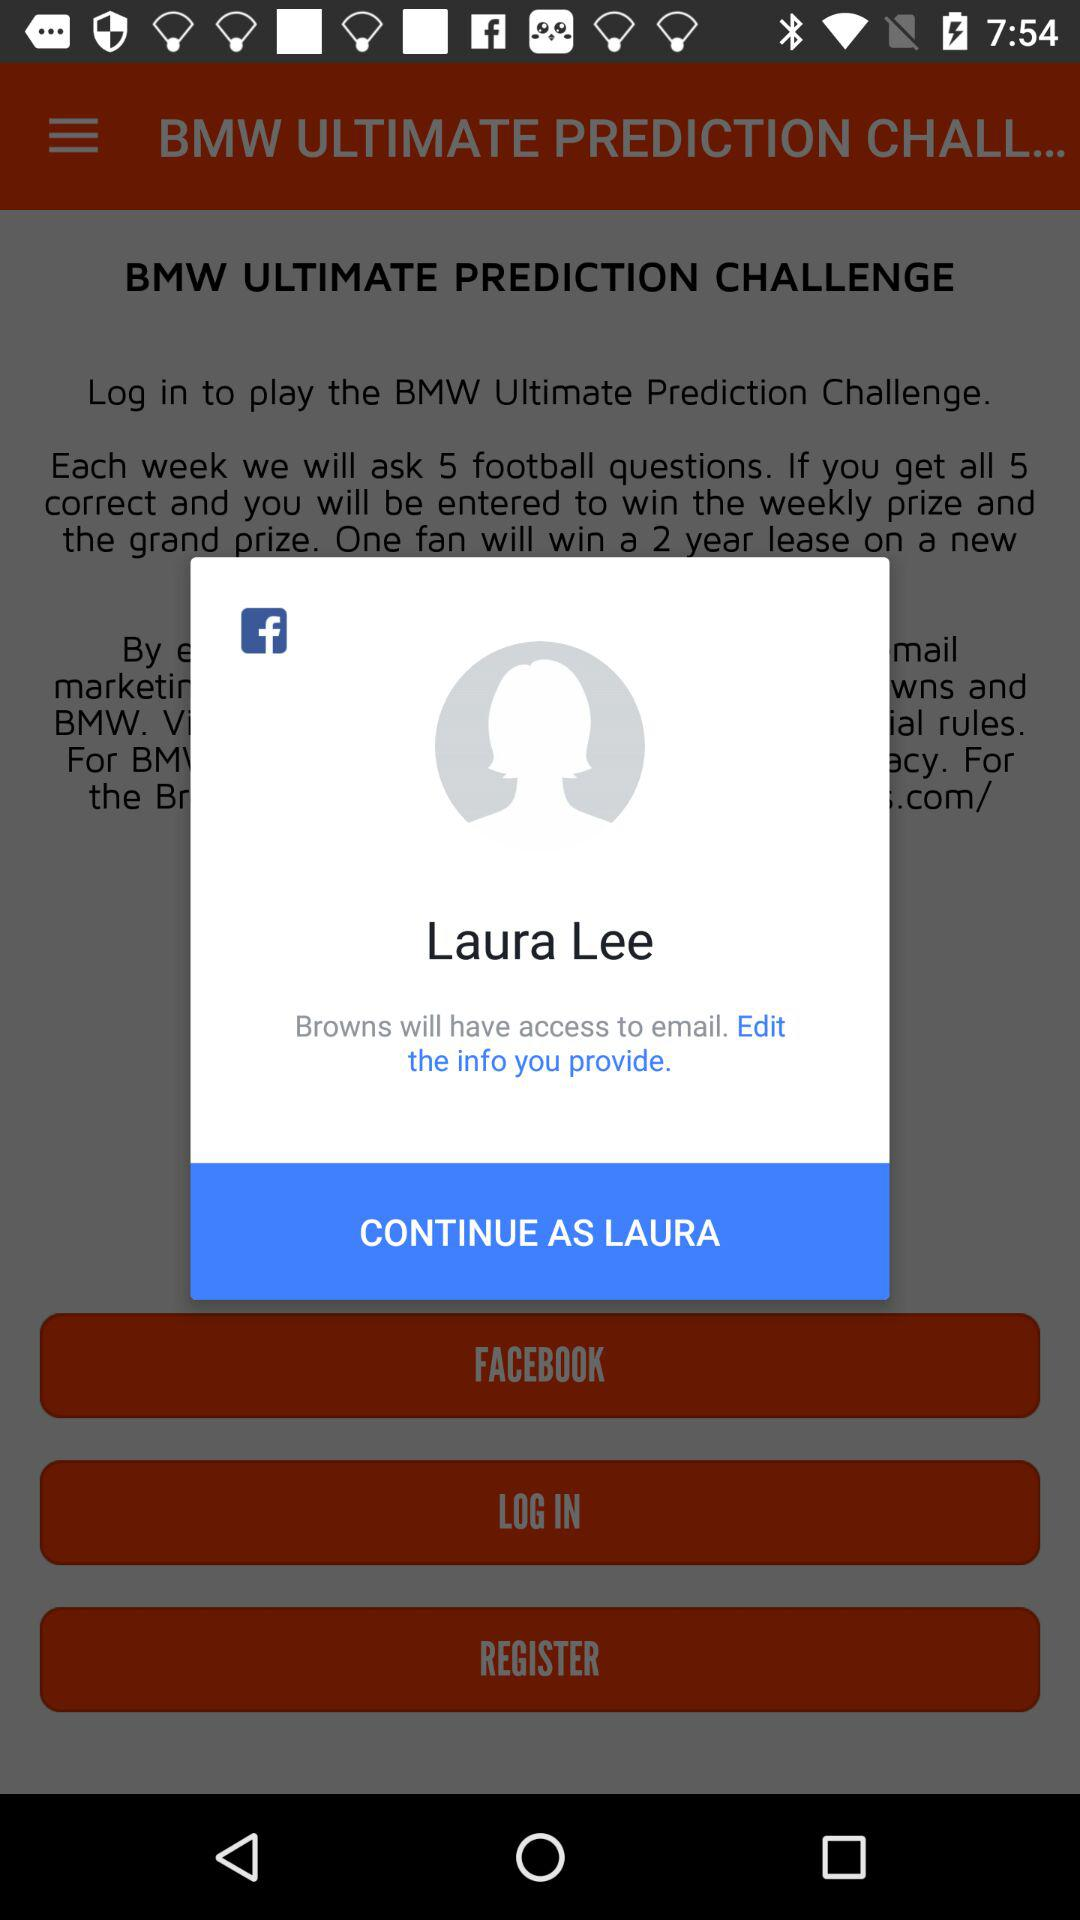What is the name of the user? The name of the user is Laura Lee. 